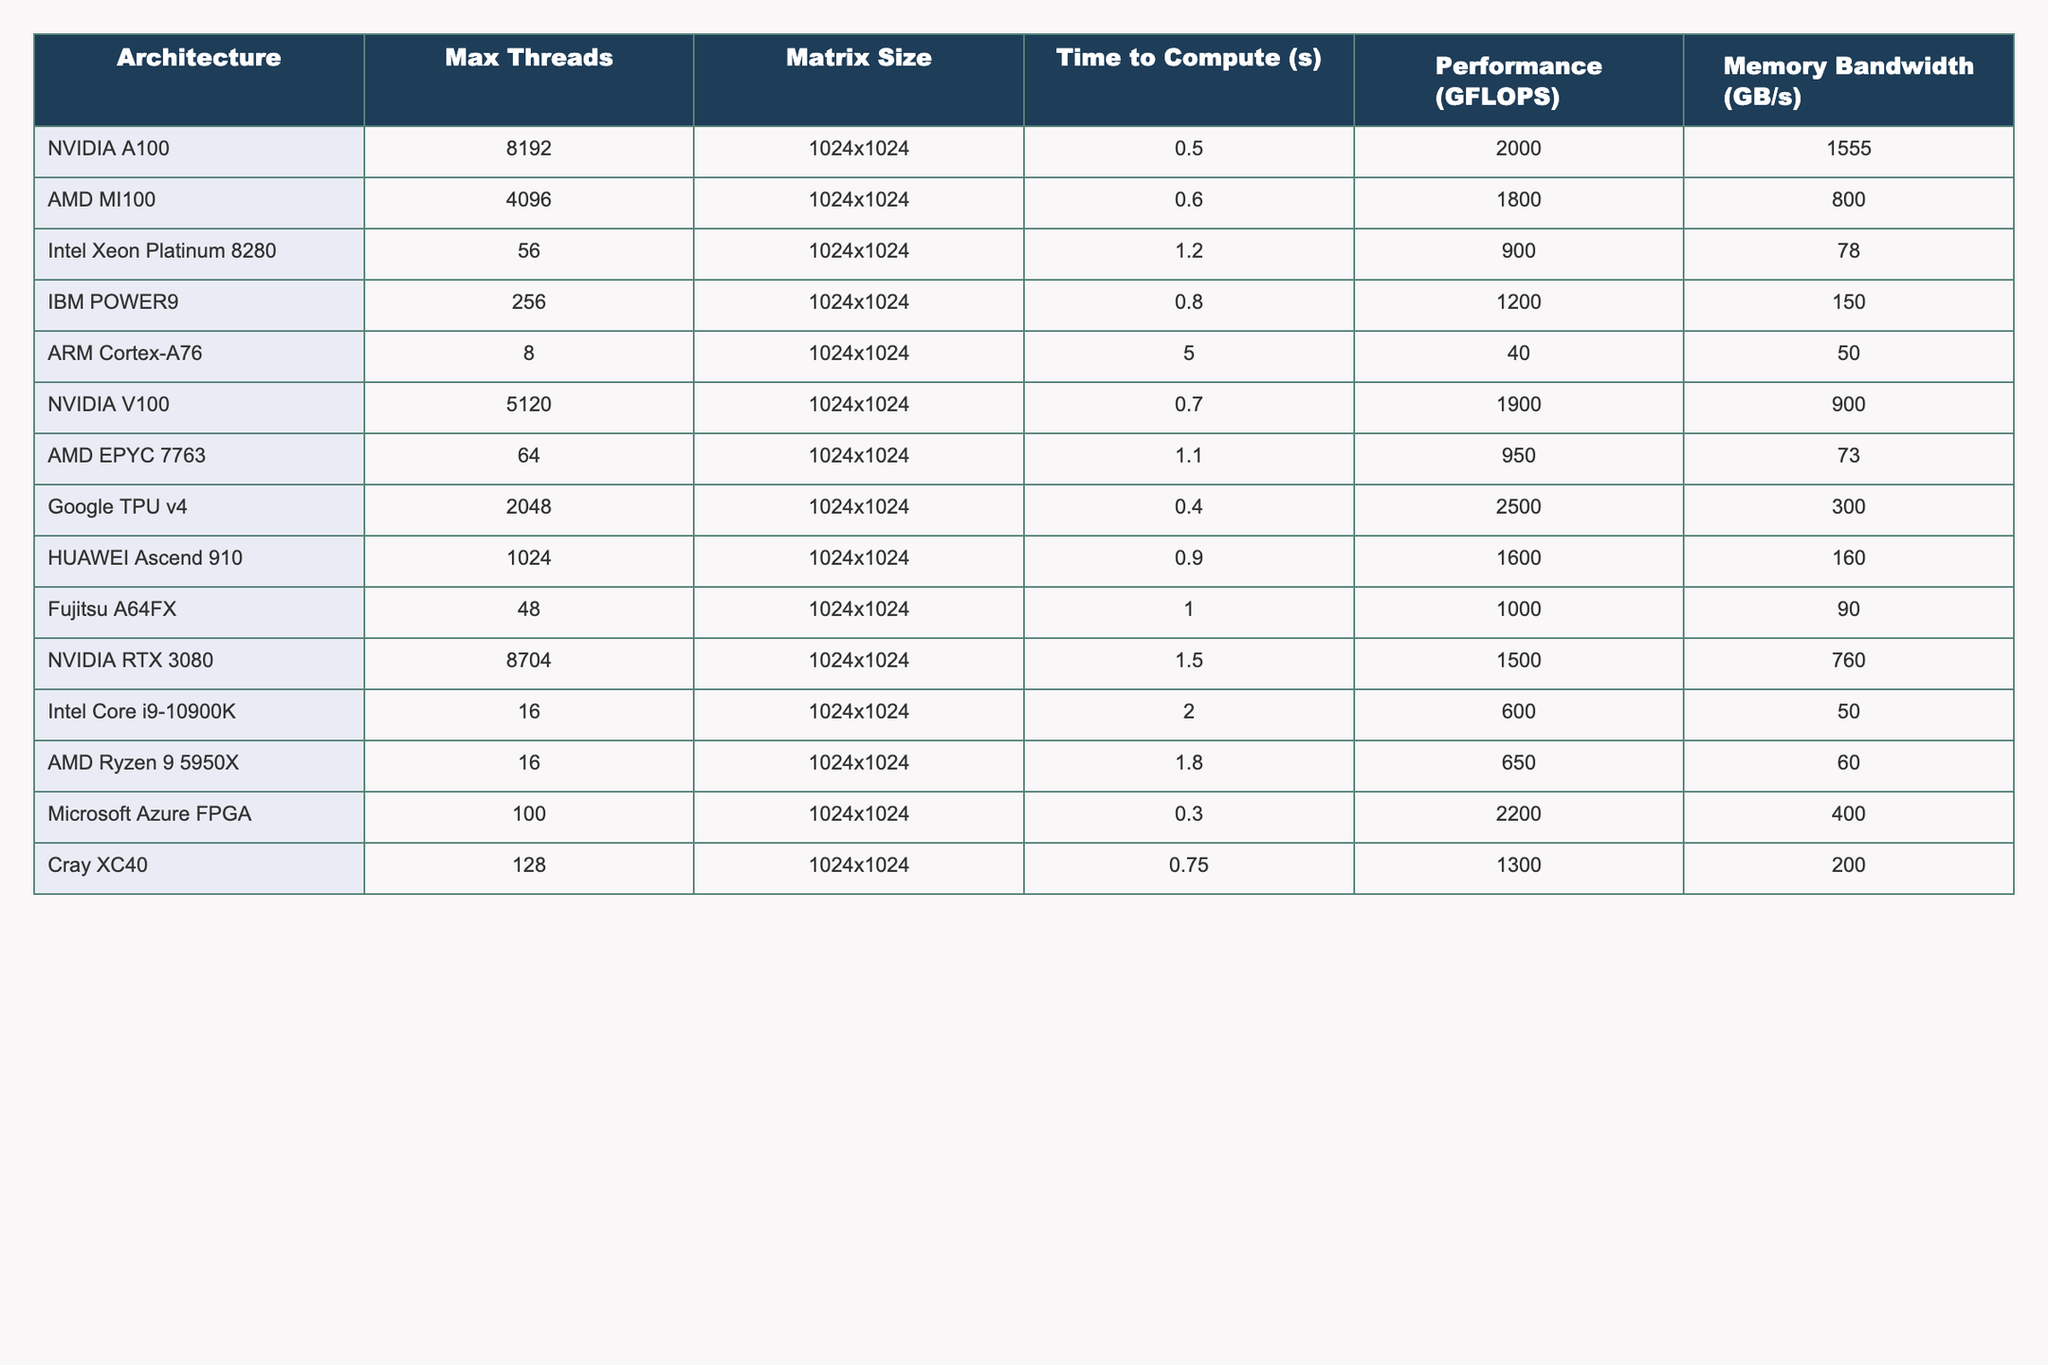What is the performance (GFLOPS) of the NVIDIA A100 architecture? The table shows that the performance of the NVIDIA A100 architecture is 2000 GFLOPS, as listed directly under the Performance column.
Answer: 2000 GFLOPS Which architecture has the highest memory bandwidth? The highest memory bandwidth in the table is 1555 GB/s, associated with the NVIDIA A100 architecture, which is stated in the Memory Bandwidth column.
Answer: NVIDIA A100 What is the average time to compute among the given architectures? To find the average time: add all compute times (0.5 + 0.6 + 1.2 + 0.8 + 5.0 + 0.7 + 1.1 + 0.4 + 0.9 + 1.0 + 1.5 + 2.0 + 1.8 + 0.3 + 0.75 = 15.55 seconds) and divide by the total number of architectures (15). This gives an average of 15.55 / 15 ≈ 1.04 seconds.
Answer: 1.04 seconds Is the performance of the Google TPU v4 architecture greater than or equal to 2000 GFLOPS? The performance of the Google TPU v4 is 2500 GFLOPS, which is greater than 2000 GFLOPS, as indicated in the Performance column.
Answer: Yes Which architecture has the second lowest time to compute? The second lowest time to compute is found by analyzing the Time to Compute column. The lowest is 0.3 seconds (Microsoft Azure FPGA), and the second lowest is 0.4 seconds (Google TPU v4).
Answer: Google TPU v4 If we add the performance of all architectures, what would be the total GFLOPS? Sum all the performance values: (2000 + 1800 + 900 + 1200 + 40 + 1900 + 950 + 2500 + 1600 + 1000 + 1500 + 600 + 650 + 2200 + 1300) = 17590 GFLOPS.
Answer: 17590 GFLOPS How does the performance of the AMD MI100 compare to that of the AMD EPYC 7763? The AMD MI100 has a performance of 1800 GFLOPS while the AMD EPYC 7763 has a performance of 950 GFLOPS. Since 1800 is greater than 950, MI100 performs better.
Answer: AMD MI100 performs better Which architecture has the minimum maximum threads available? The architecture with the minimum Max Threads is ARM Cortex-A76, with only 8 maximum threads listed under the Max Threads column.
Answer: ARM Cortex-A76 Is the average memory bandwidth of the architectures exceeding 800 GB/s? To determine this, compute the average memory bandwidth: (1555 + 800 + 78 + 150 + 50 + 900 + 73 + 300 + 160 + 90 + 760 + 50 + 60 + 400 + 200) = 4760 GB/s, then divide by the total (15): 4760 / 15 ≈ 317.33 GB/s, which is less than 800 GB/s.
Answer: No What is the difference in performance between the NVIDIA V100 and the NVIDIA RTX 3080? To find the difference, subtract the NVIDIA RTX 3080 performance (1500 GFLOPS) from the NVIDIA V100 performance (1900 GFLOPS), obtaining 1900 - 1500 = 400 GFLOPS.
Answer: 400 GFLOPS 